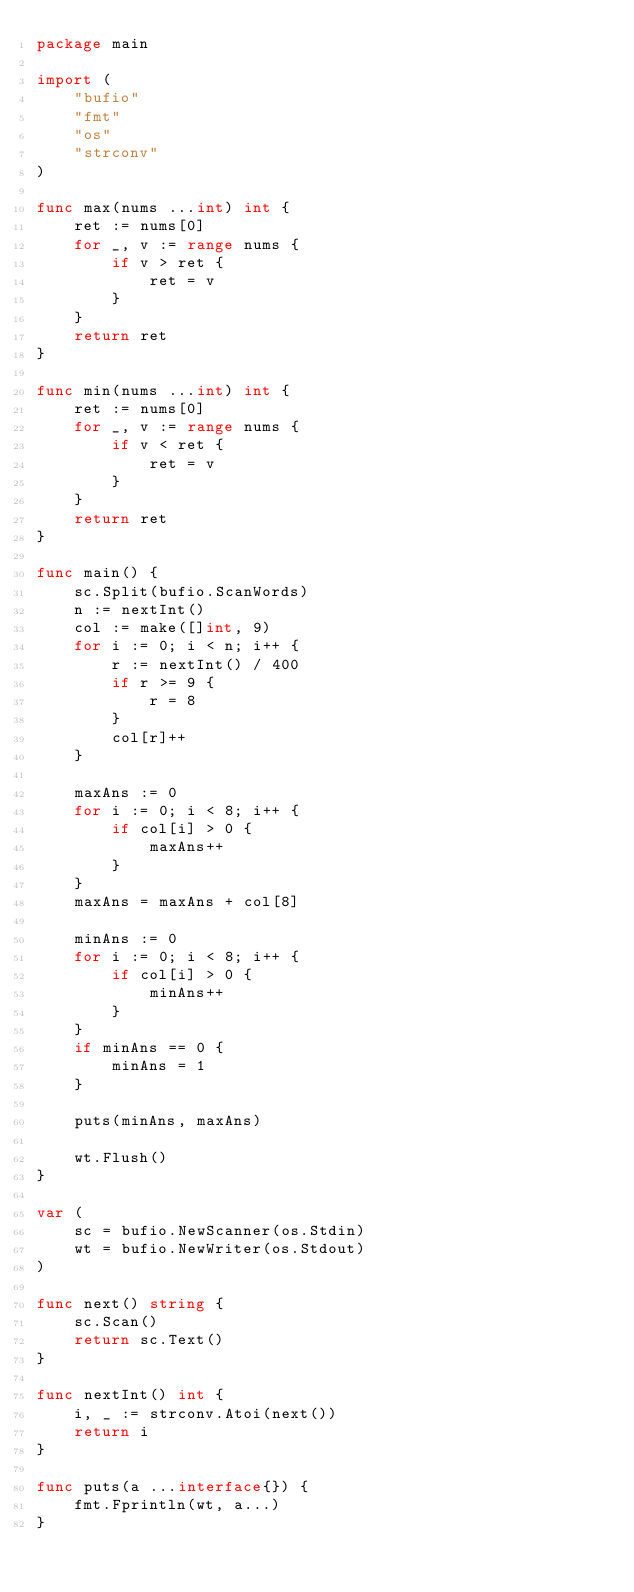Convert code to text. <code><loc_0><loc_0><loc_500><loc_500><_Go_>package main

import (
	"bufio"
	"fmt"
	"os"
	"strconv"
)

func max(nums ...int) int {
	ret := nums[0]
	for _, v := range nums {
		if v > ret {
			ret = v
		}
	}
	return ret
}

func min(nums ...int) int {
	ret := nums[0]
	for _, v := range nums {
		if v < ret {
			ret = v
		}
	}
	return ret
}

func main() {
	sc.Split(bufio.ScanWords)
	n := nextInt()
	col := make([]int, 9)
	for i := 0; i < n; i++ {
		r := nextInt() / 400
		if r >= 9 {
			r = 8
		}
		col[r]++
	}

	maxAns := 0
	for i := 0; i < 8; i++ {
		if col[i] > 0 {
			maxAns++
		}
	}
	maxAns = maxAns + col[8]

	minAns := 0
	for i := 0; i < 8; i++ {
		if col[i] > 0 {
			minAns++
		}
	}
	if minAns == 0 {
		minAns = 1
	}

	puts(minAns, maxAns)

	wt.Flush()
}

var (
	sc = bufio.NewScanner(os.Stdin)
	wt = bufio.NewWriter(os.Stdout)
)

func next() string {
	sc.Scan()
	return sc.Text()
}

func nextInt() int {
	i, _ := strconv.Atoi(next())
	return i
}

func puts(a ...interface{}) {
	fmt.Fprintln(wt, a...)
}
</code> 